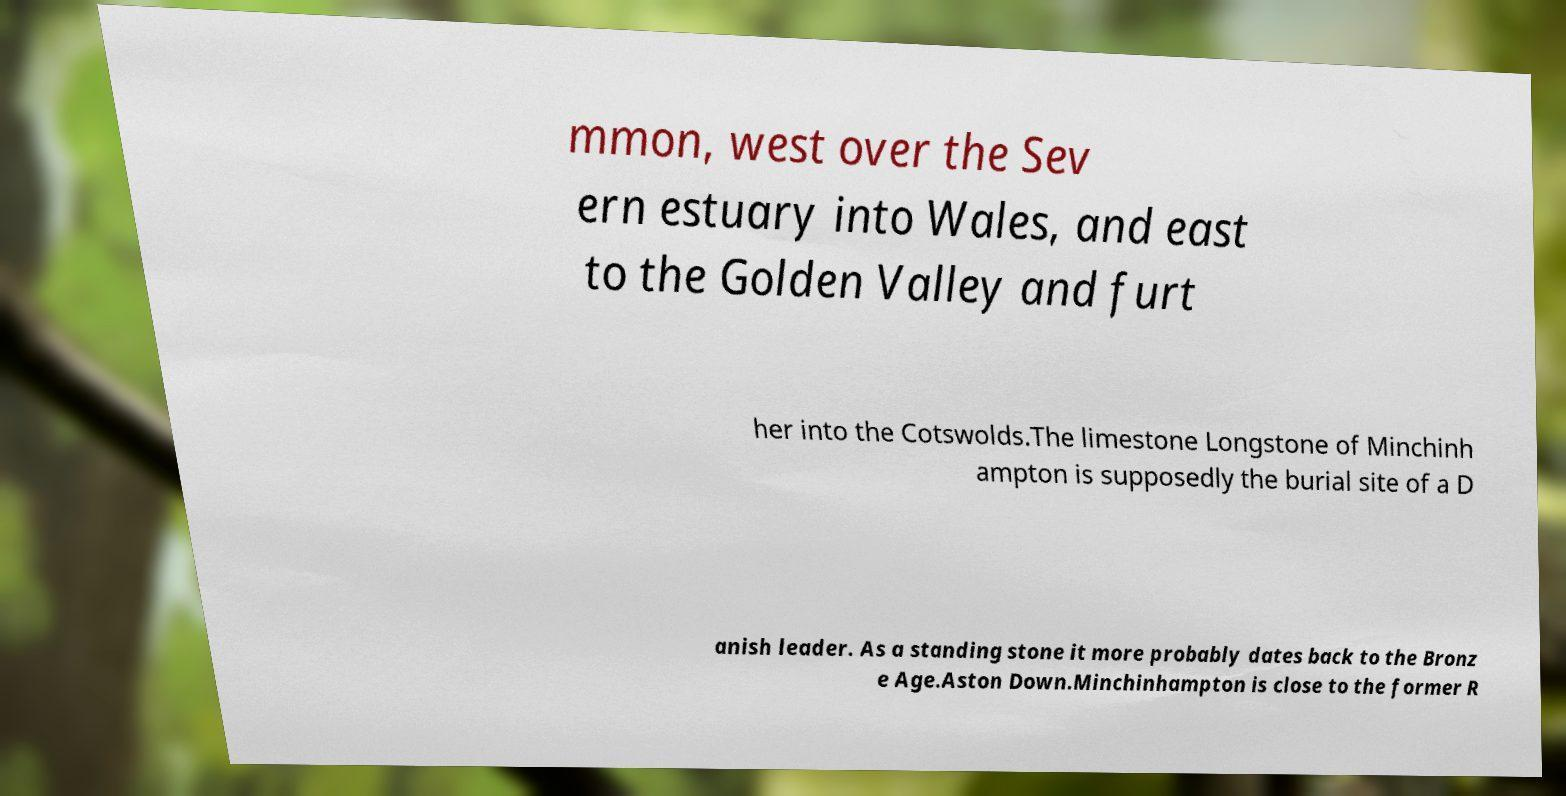Please identify and transcribe the text found in this image. mmon, west over the Sev ern estuary into Wales, and east to the Golden Valley and furt her into the Cotswolds.The limestone Longstone of Minchinh ampton is supposedly the burial site of a D anish leader. As a standing stone it more probably dates back to the Bronz e Age.Aston Down.Minchinhampton is close to the former R 